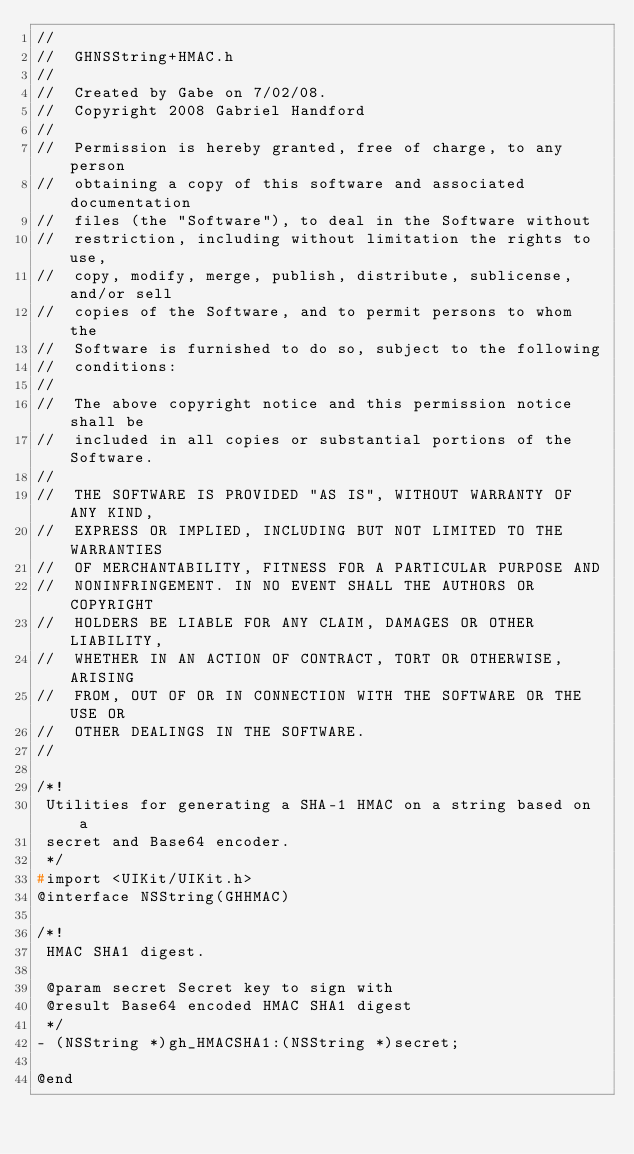<code> <loc_0><loc_0><loc_500><loc_500><_C_>//
//  GHNSString+HMAC.h
//
//  Created by Gabe on 7/02/08.
//  Copyright 2008 Gabriel Handford
//
//  Permission is hereby granted, free of charge, to any person
//  obtaining a copy of this software and associated documentation
//  files (the "Software"), to deal in the Software without
//  restriction, including without limitation the rights to use,
//  copy, modify, merge, publish, distribute, sublicense, and/or sell
//  copies of the Software, and to permit persons to whom the
//  Software is furnished to do so, subject to the following
//  conditions:
//
//  The above copyright notice and this permission notice shall be
//  included in all copies or substantial portions of the Software.
//
//  THE SOFTWARE IS PROVIDED "AS IS", WITHOUT WARRANTY OF ANY KIND,
//  EXPRESS OR IMPLIED, INCLUDING BUT NOT LIMITED TO THE WARRANTIES
//  OF MERCHANTABILITY, FITNESS FOR A PARTICULAR PURPOSE AND
//  NONINFRINGEMENT. IN NO EVENT SHALL THE AUTHORS OR COPYRIGHT
//  HOLDERS BE LIABLE FOR ANY CLAIM, DAMAGES OR OTHER LIABILITY,
//  WHETHER IN AN ACTION OF CONTRACT, TORT OR OTHERWISE, ARISING
//  FROM, OUT OF OR IN CONNECTION WITH THE SOFTWARE OR THE USE OR
//  OTHER DEALINGS IN THE SOFTWARE.
//

/*!
 Utilities for generating a SHA-1 HMAC on a string based on a
 secret and Base64 encoder.
 */
#import <UIKit/UIKit.h>
@interface NSString(GHHMAC)

/*!
 HMAC SHA1 digest.

 @param secret Secret key to sign with
 @result Base64 encoded HMAC SHA1 digest
 */
- (NSString *)gh_HMACSHA1:(NSString *)secret;

@end
</code> 